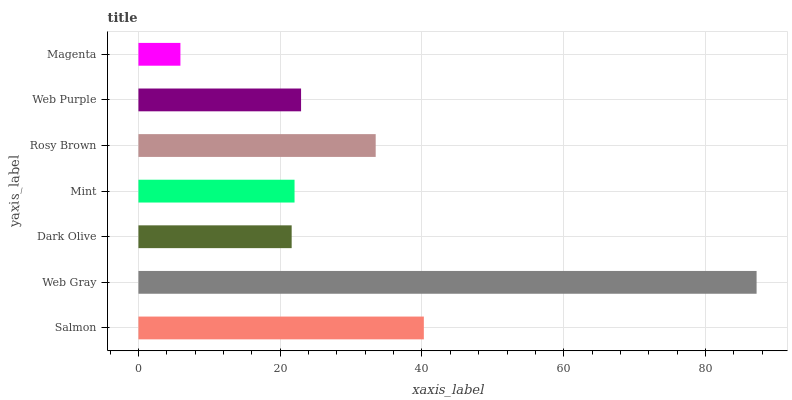Is Magenta the minimum?
Answer yes or no. Yes. Is Web Gray the maximum?
Answer yes or no. Yes. Is Dark Olive the minimum?
Answer yes or no. No. Is Dark Olive the maximum?
Answer yes or no. No. Is Web Gray greater than Dark Olive?
Answer yes or no. Yes. Is Dark Olive less than Web Gray?
Answer yes or no. Yes. Is Dark Olive greater than Web Gray?
Answer yes or no. No. Is Web Gray less than Dark Olive?
Answer yes or no. No. Is Web Purple the high median?
Answer yes or no. Yes. Is Web Purple the low median?
Answer yes or no. Yes. Is Dark Olive the high median?
Answer yes or no. No. Is Salmon the low median?
Answer yes or no. No. 